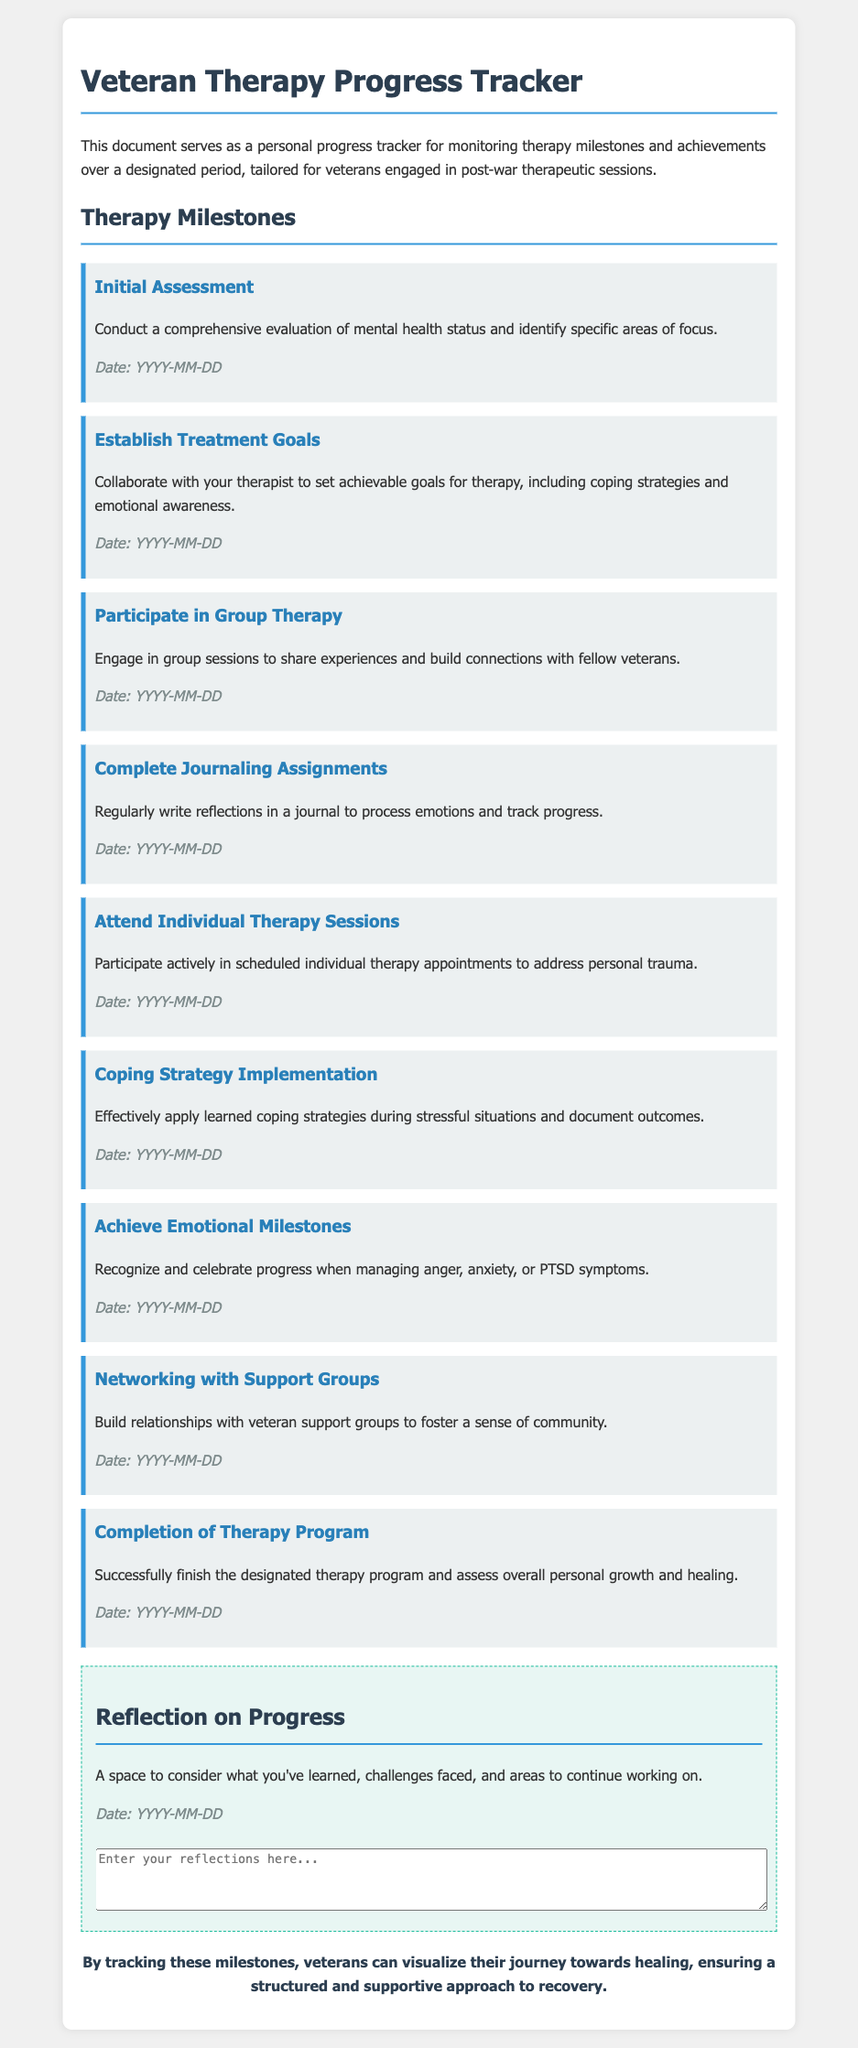What is the title of the document? The title is shown prominently at the top of the document, indicating its purpose.
Answer: Veteran Therapy Progress Tracker How many therapy milestones are listed? Each milestone is presented as a separate section within the document.
Answer: Nine What is the first milestone mentioned? The first milestone appears at the beginning of the milestones section.
Answer: Initial Assessment What type of therapy is suggested for building connections with fellow veterans? This therapy involves engaging with others who share similar experiences.
Answer: Group Therapy What is the purpose of the reflection section? The reflection section encourages personal consideration of the therapy journey, challenges, and learning.
Answer: To consider what you've learned What does the conclusion emphasize? The conclusion reflects on the overall aim of the progress tracker for veterans.
Answer: Visualize their journey towards healing What date format is suggested for entering milestones? The document specifies a format for date entry.
Answer: YYYY-MM-DD Which milestone focuses on learning coping strategies? This milestone emphasizes the application of knowledge gained in therapy.
Answer: Coping Strategy Implementation What is a requirement for the completion of the therapy program? Completing the program and assessing personal growth is detailed.
Answer: Successful finish 